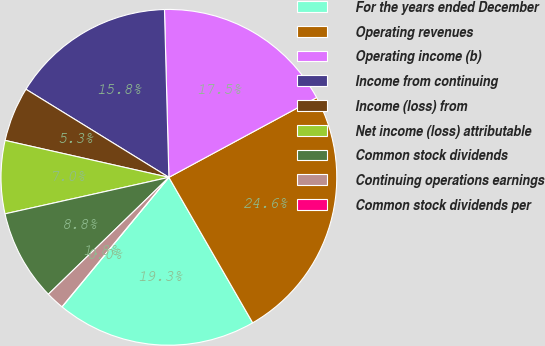Convert chart. <chart><loc_0><loc_0><loc_500><loc_500><pie_chart><fcel>For the years ended December<fcel>Operating revenues<fcel>Operating income (b)<fcel>Income from continuing<fcel>Income (loss) from<fcel>Net income (loss) attributable<fcel>Common stock dividends<fcel>Continuing operations earnings<fcel>Common stock dividends per<nl><fcel>19.3%<fcel>24.56%<fcel>17.54%<fcel>15.79%<fcel>5.26%<fcel>7.02%<fcel>8.77%<fcel>1.76%<fcel>0.0%<nl></chart> 